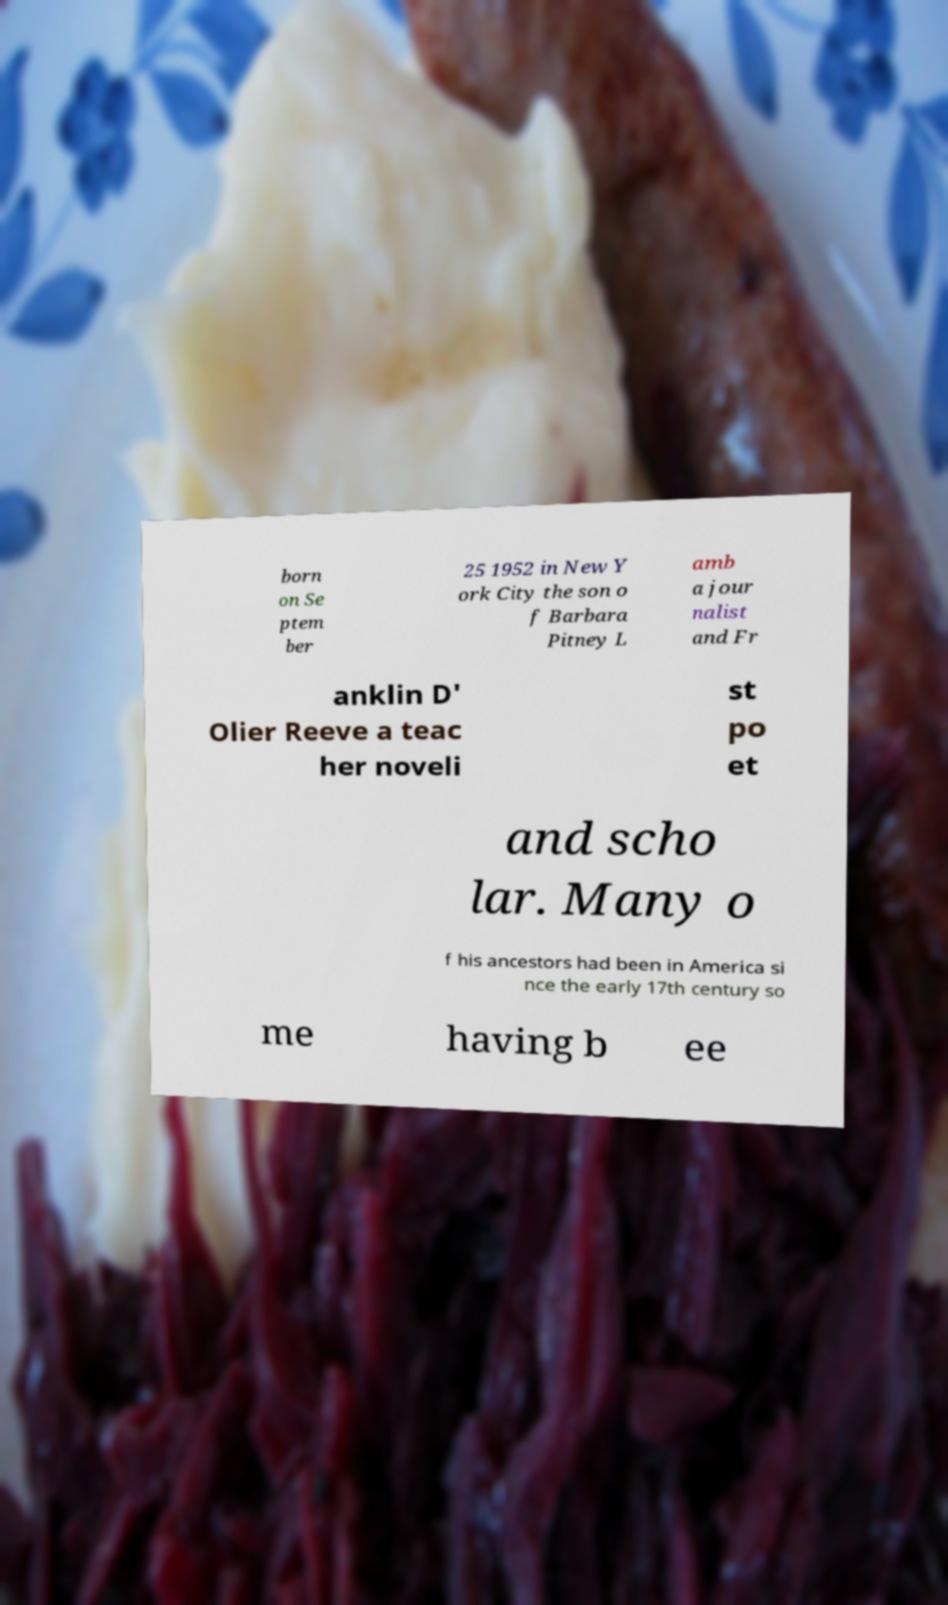Could you assist in decoding the text presented in this image and type it out clearly? born on Se ptem ber 25 1952 in New Y ork City the son o f Barbara Pitney L amb a jour nalist and Fr anklin D' Olier Reeve a teac her noveli st po et and scho lar. Many o f his ancestors had been in America si nce the early 17th century so me having b ee 